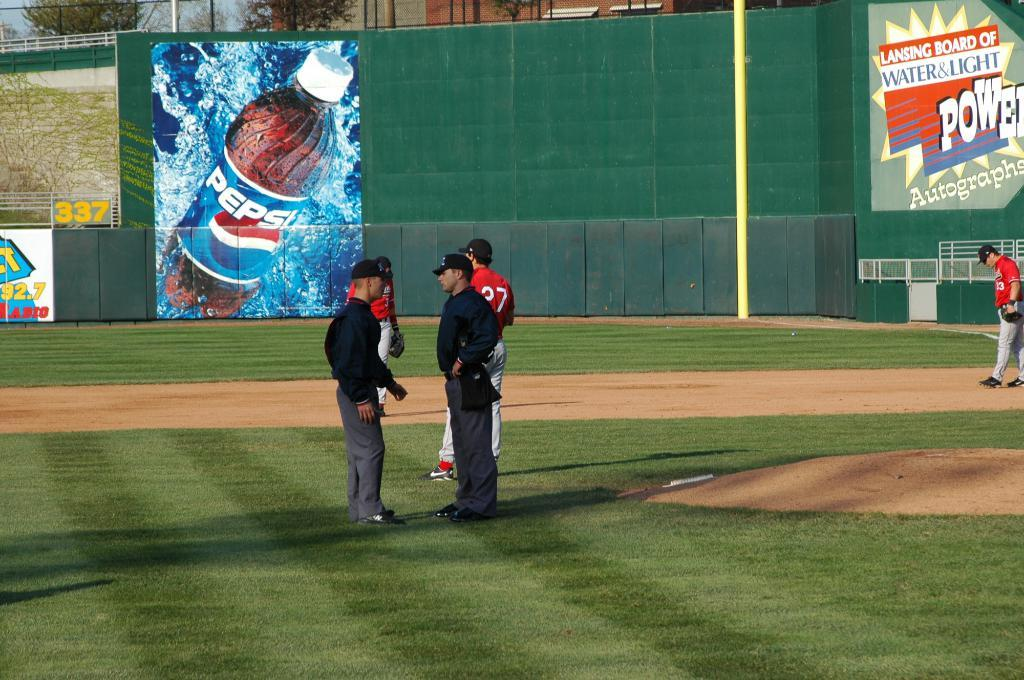Provide a one-sentence caption for the provided image. Behind the players and umpires is a big Pepsi advertisement. 